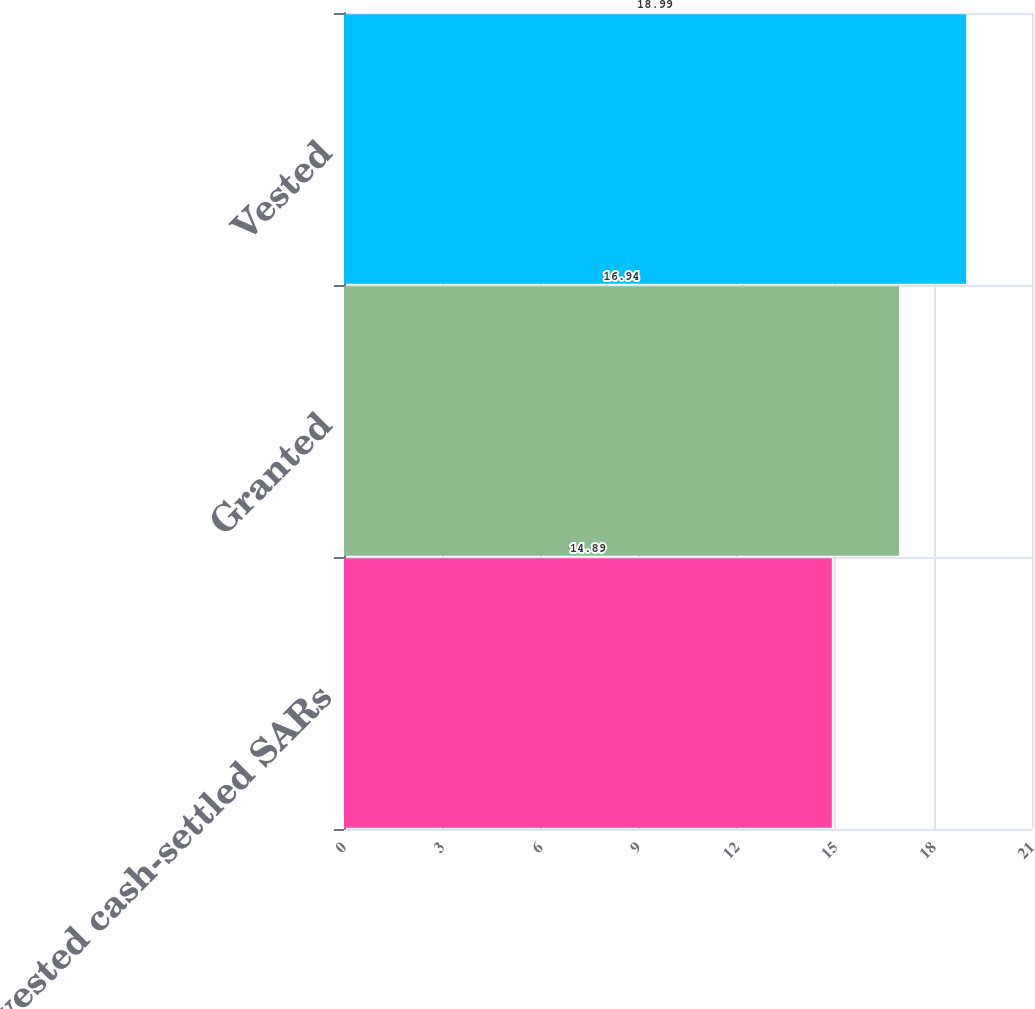Convert chart. <chart><loc_0><loc_0><loc_500><loc_500><bar_chart><fcel>Non-vested cash-settled SARs<fcel>Granted<fcel>Vested<nl><fcel>14.89<fcel>16.94<fcel>18.99<nl></chart> 